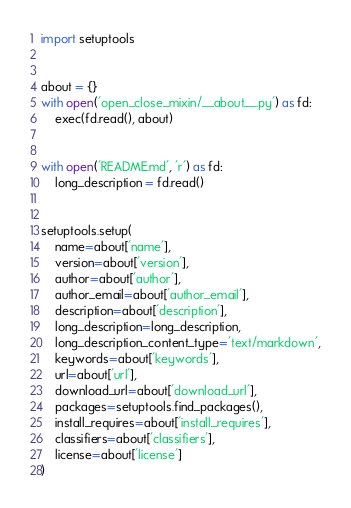Convert code to text. <code><loc_0><loc_0><loc_500><loc_500><_Python_>import setuptools


about = {}
with open('open_close_mixin/__about__.py') as fd:
    exec(fd.read(), about)


with open('README.md', 'r') as fd:
    long_description = fd.read()


setuptools.setup(
    name=about['name'],
    version=about['version'],
    author=about['author'],
    author_email=about['author_email'],
    description=about['description'],
    long_description=long_description,
    long_description_content_type='text/markdown',
    keywords=about['keywords'],
    url=about['url'],
    download_url=about['download_url'],
    packages=setuptools.find_packages(),
    install_requires=about['install_requires'],
    classifiers=about['classifiers'],
    license=about['license']
)
</code> 